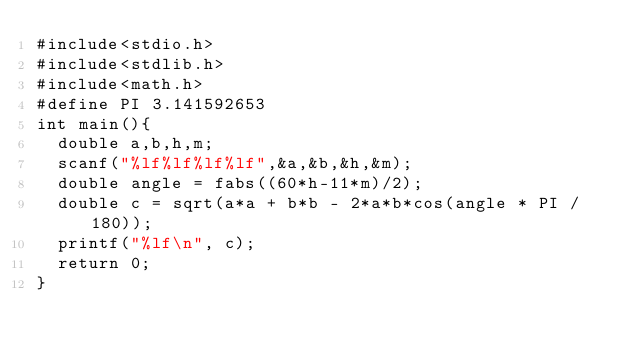<code> <loc_0><loc_0><loc_500><loc_500><_C_>#include<stdio.h>
#include<stdlib.h>
#include<math.h>
#define PI 3.141592653
int main(){
  double a,b,h,m;
  scanf("%lf%lf%lf%lf",&a,&b,&h,&m);
  double angle = fabs((60*h-11*m)/2);
  double c = sqrt(a*a + b*b - 2*a*b*cos(angle * PI / 180));
  printf("%lf\n", c);
  return 0;
}
</code> 